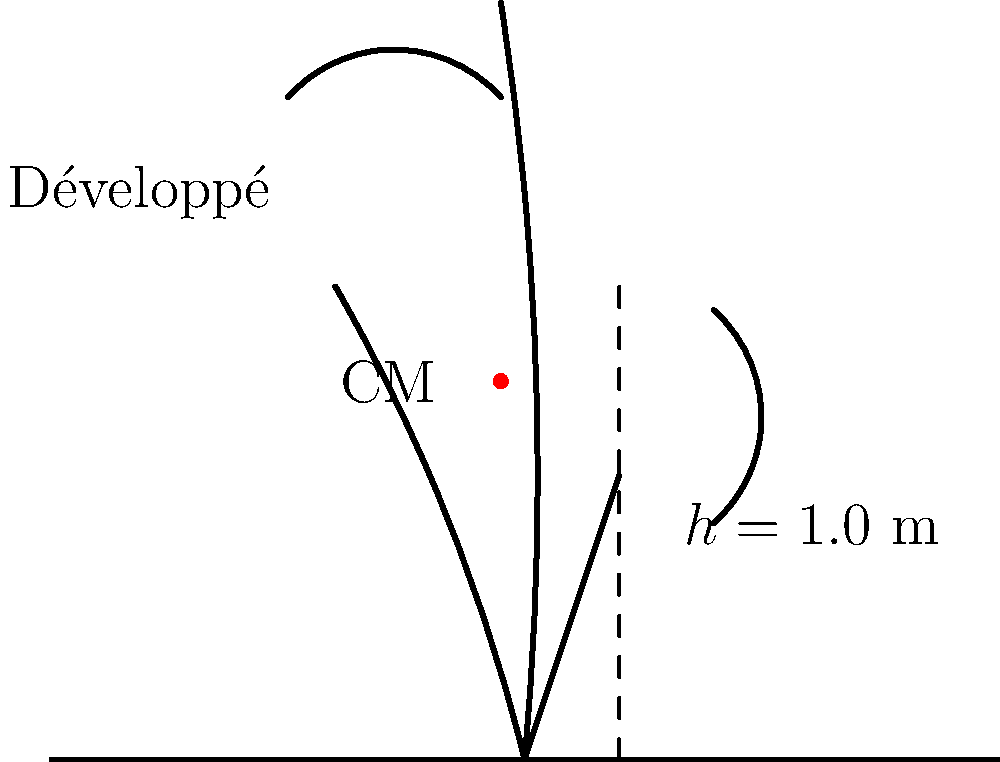A ballet dancer performs a développé, raising their leg to a height of 1.0 m as shown in the figure. If the dancer's center of mass (CM) rises by 0.2 m during this movement and the dancer has a mass of 50 kg, calculate the change in gravitational potential energy and the minimum kinetic energy required to perform this movement. Assume g = 9.8 m/s². Let's approach this step-by-step:

1. Change in Gravitational Potential Energy:
   The change in gravitational potential energy is given by the formula:
   $$\Delta PE = m \cdot g \cdot \Delta h$$
   Where:
   $m$ = mass of the dancer = 50 kg
   $g$ = acceleration due to gravity = 9.8 m/s²
   $\Delta h$ = change in height of the center of mass = 0.2 m

   Plugging in the values:
   $$\Delta PE = 50 \text{ kg} \cdot 9.8 \text{ m/s²} \cdot 0.2 \text{ m} = 98 \text{ J}$$

2. Minimum Kinetic Energy:
   The minimum kinetic energy required to perform this movement would be equal to the change in potential energy. This is because, in an ideal scenario, all the initial kinetic energy would be converted to potential energy at the highest point of the movement.

   Therefore, the minimum kinetic energy is also 98 J.

Note: In reality, the kinetic energy required would be slightly higher due to factors like air resistance and muscle inefficiencies, but for the purposes of this physics problem, we assume an ideal scenario.
Answer: Change in PE = 98 J, Minimum KE = 98 J 